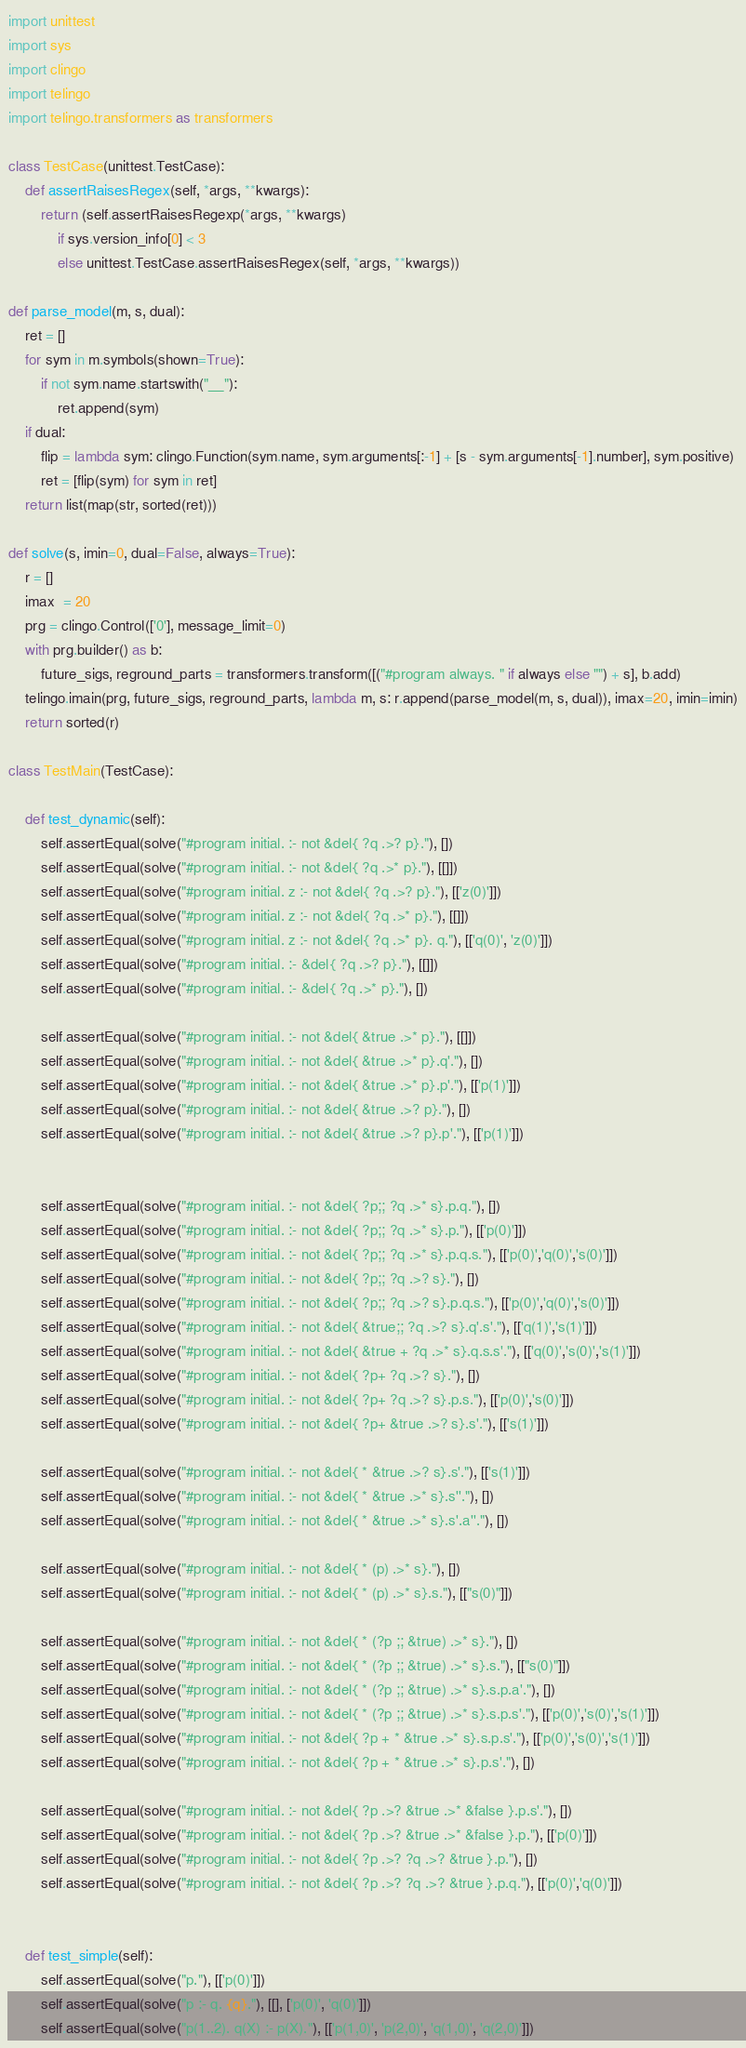Convert code to text. <code><loc_0><loc_0><loc_500><loc_500><_Python_>import unittest
import sys
import clingo
import telingo
import telingo.transformers as transformers

class TestCase(unittest.TestCase):
    def assertRaisesRegex(self, *args, **kwargs):
        return (self.assertRaisesRegexp(*args, **kwargs)
            if sys.version_info[0] < 3
            else unittest.TestCase.assertRaisesRegex(self, *args, **kwargs))

def parse_model(m, s, dual):
    ret = []
    for sym in m.symbols(shown=True):
        if not sym.name.startswith("__"):
            ret.append(sym)
    if dual:
        flip = lambda sym: clingo.Function(sym.name, sym.arguments[:-1] + [s - sym.arguments[-1].number], sym.positive)
        ret = [flip(sym) for sym in ret]
    return list(map(str, sorted(ret)))

def solve(s, imin=0, dual=False, always=True):
    r = []
    imax  = 20
    prg = clingo.Control(['0'], message_limit=0)
    with prg.builder() as b:
        future_sigs, reground_parts = transformers.transform([("#program always. " if always else "") + s], b.add)
    telingo.imain(prg, future_sigs, reground_parts, lambda m, s: r.append(parse_model(m, s, dual)), imax=20, imin=imin)
    return sorted(r)

class TestMain(TestCase):

    def test_dynamic(self):
        self.assertEqual(solve("#program initial. :- not &del{ ?q .>? p}."), [])
        self.assertEqual(solve("#program initial. :- not &del{ ?q .>* p}."), [[]])
        self.assertEqual(solve("#program initial. z :- not &del{ ?q .>? p}."), [['z(0)']])
        self.assertEqual(solve("#program initial. z :- not &del{ ?q .>* p}."), [[]])
        self.assertEqual(solve("#program initial. z :- not &del{ ?q .>* p}. q."), [['q(0)', 'z(0)']])
        self.assertEqual(solve("#program initial. :- &del{ ?q .>? p}."), [[]])
        self.assertEqual(solve("#program initial. :- &del{ ?q .>* p}."), [])

        self.assertEqual(solve("#program initial. :- not &del{ &true .>* p}."), [[]])
        self.assertEqual(solve("#program initial. :- not &del{ &true .>* p}.q'."), [])
        self.assertEqual(solve("#program initial. :- not &del{ &true .>* p}.p'."), [['p(1)']])
        self.assertEqual(solve("#program initial. :- not &del{ &true .>? p}."), [])
        self.assertEqual(solve("#program initial. :- not &del{ &true .>? p}.p'."), [['p(1)']])


        self.assertEqual(solve("#program initial. :- not &del{ ?p;; ?q .>* s}.p.q."), [])
        self.assertEqual(solve("#program initial. :- not &del{ ?p;; ?q .>* s}.p."), [['p(0)']])
        self.assertEqual(solve("#program initial. :- not &del{ ?p;; ?q .>* s}.p.q.s."), [['p(0)','q(0)','s(0)']])
        self.assertEqual(solve("#program initial. :- not &del{ ?p;; ?q .>? s}."), [])
        self.assertEqual(solve("#program initial. :- not &del{ ?p;; ?q .>? s}.p.q.s."), [['p(0)','q(0)','s(0)']])
        self.assertEqual(solve("#program initial. :- not &del{ &true;; ?q .>? s}.q'.s'."), [['q(1)','s(1)']])
        self.assertEqual(solve("#program initial. :- not &del{ &true + ?q .>* s}.q.s.s'."), [['q(0)','s(0)','s(1)']])
        self.assertEqual(solve("#program initial. :- not &del{ ?p+ ?q .>? s}."), [])
        self.assertEqual(solve("#program initial. :- not &del{ ?p+ ?q .>? s}.p.s."), [['p(0)','s(0)']])
        self.assertEqual(solve("#program initial. :- not &del{ ?p+ &true .>? s}.s'."), [['s(1)']])

        self.assertEqual(solve("#program initial. :- not &del{ * &true .>? s}.s'."), [['s(1)']])
        self.assertEqual(solve("#program initial. :- not &del{ * &true .>* s}.s''."), [])
        self.assertEqual(solve("#program initial. :- not &del{ * &true .>* s}.s'.a''."), [])

        self.assertEqual(solve("#program initial. :- not &del{ * (p) .>* s}."), [])
        self.assertEqual(solve("#program initial. :- not &del{ * (p) .>* s}.s."), [["s(0)"]])

        self.assertEqual(solve("#program initial. :- not &del{ * (?p ;; &true) .>* s}."), [])
        self.assertEqual(solve("#program initial. :- not &del{ * (?p ;; &true) .>* s}.s."), [["s(0)"]])
        self.assertEqual(solve("#program initial. :- not &del{ * (?p ;; &true) .>* s}.s.p.a'."), [])
        self.assertEqual(solve("#program initial. :- not &del{ * (?p ;; &true) .>* s}.s.p.s'."), [['p(0)','s(0)','s(1)']])
        self.assertEqual(solve("#program initial. :- not &del{ ?p + * &true .>* s}.s.p.s'."), [['p(0)','s(0)','s(1)']])
        self.assertEqual(solve("#program initial. :- not &del{ ?p + * &true .>* s}.p.s'."), [])

        self.assertEqual(solve("#program initial. :- not &del{ ?p .>? &true .>* &false }.p.s'."), [])
        self.assertEqual(solve("#program initial. :- not &del{ ?p .>? &true .>* &false }.p."), [['p(0)']])
        self.assertEqual(solve("#program initial. :- not &del{ ?p .>? ?q .>? &true }.p."), [])
        self.assertEqual(solve("#program initial. :- not &del{ ?p .>? ?q .>? &true }.p.q."), [['p(0)','q(0)']])


    def test_simple(self):
        self.assertEqual(solve("p."), [['p(0)']])
        self.assertEqual(solve("p :- q. {q}."), [[], ['p(0)', 'q(0)']])
        self.assertEqual(solve("p(1..2). q(X) :- p(X)."), [['p(1,0)', 'p(2,0)', 'q(1,0)', 'q(2,0)']])</code> 